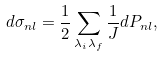Convert formula to latex. <formula><loc_0><loc_0><loc_500><loc_500>d \sigma _ { n l } = \frac { 1 } { 2 } \sum _ { \lambda _ { i } \lambda _ { f } } \frac { 1 } { J } d P _ { n l } ,</formula> 